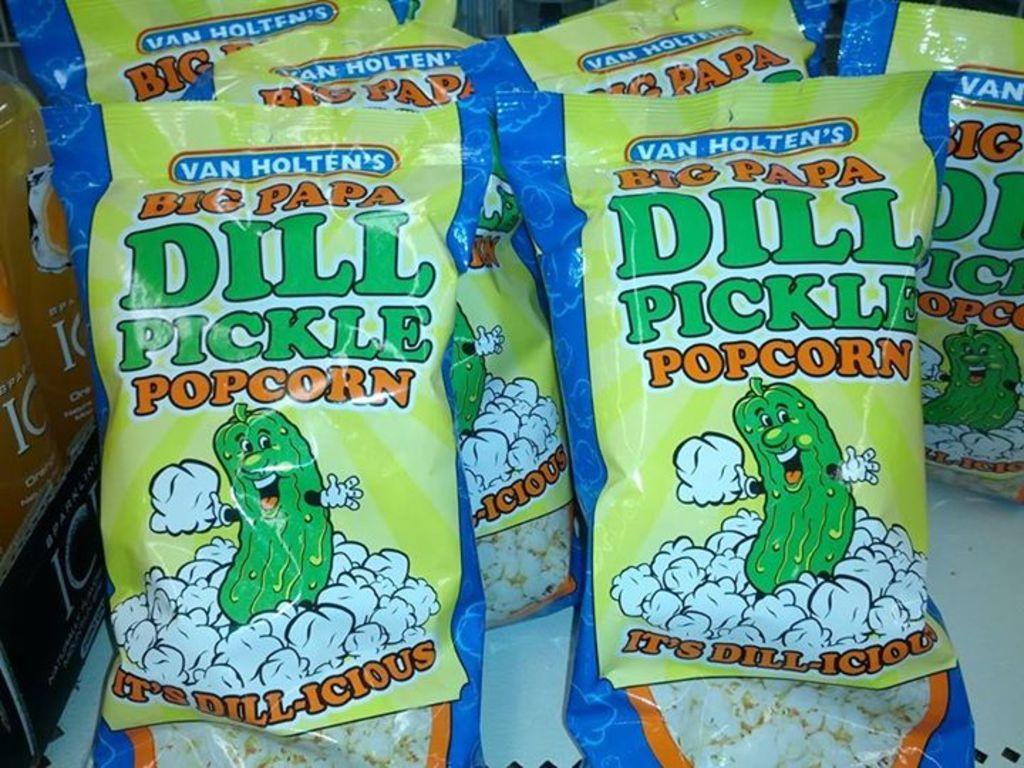In one or two sentences, can you explain what this image depicts? In this image we can see there are packets with image and text. And at the side there is a drink in the bottle. And there is a black color object. 